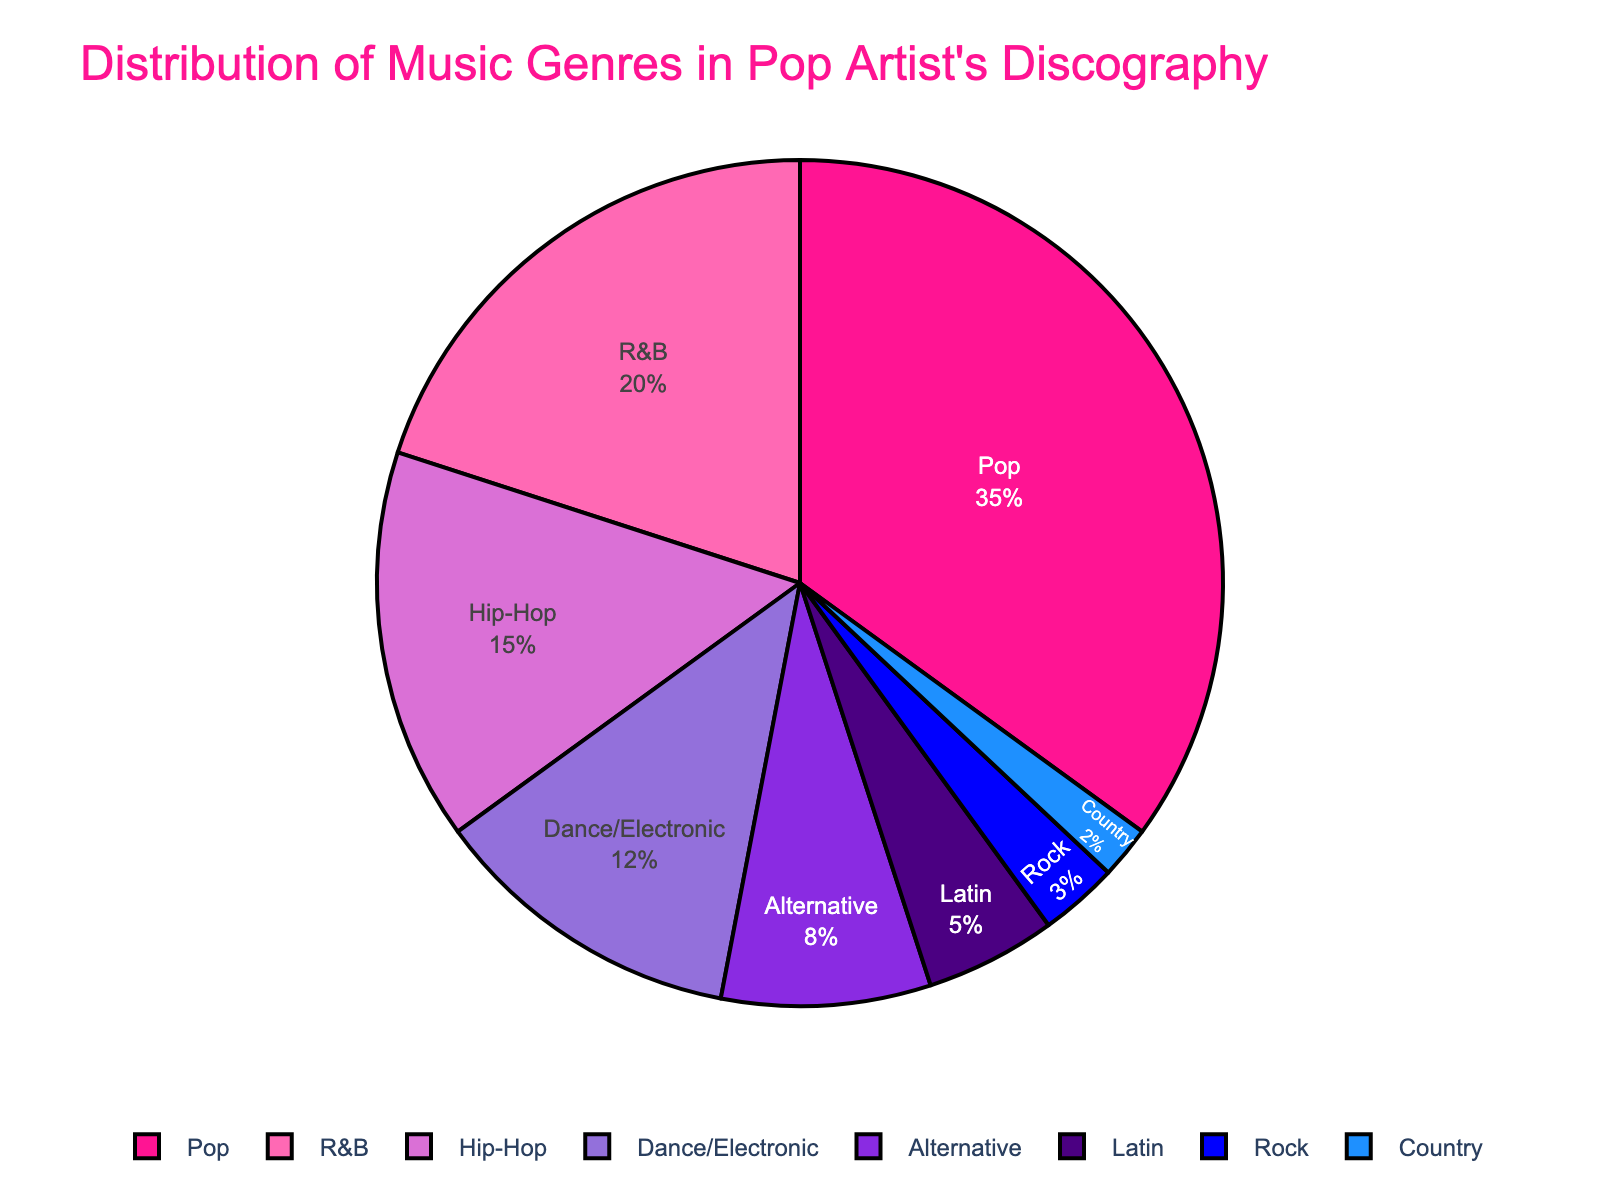Which genre has the largest percentage in the pop artist's discography? The chart shows that the Pop genre has the largest section, taking up 35% of the pie chart.
Answer: Pop Which genre has the smallest percentage in the pop artist's discography? The Country genre has the smallest section in the pie chart, indicated at 2%.
Answer: Country What is the combined percentage of Hip-Hop, Dance/Electronic, and Alternative genres? Sum the percentages for Hip-Hop (15%), Dance/Electronic (12%), and Alternative (8%): 15 + 12 + 8 = 35%
Answer: 35% Is the percentage of R&B greater than the combination of Rock and Country? The percentage of R&B is 20%. The combined percentage of Rock (3%) and Country (2%) is 5%. Since 20% > 5%, yes, R&B is greater.
Answer: Yes Which genres have a percentage less than 10%? The four smallest sections are Alternative (8%), Latin (5%), Rock (3%), and Country (2%).
Answer: Alternative, Latin, Rock, Country How does the percentage of Pop compare to the sum of Latin and Rock? The percentage of Pop is 35%. The sum of Latin (5%) and Rock (3%) is 5 + 3 = 8%. Since 35% > 8%, Pop is larger.
Answer: Pop is larger What is the combined percentage of all genres with more than 10% each? Sum the percentages for Pop (35%), R&B (20%), Hip-Hop (15%), and Dance/Electronic (12%): 35 + 20 + 15 + 12 = 82%
Answer: 82% How does the visual appearance of the Pop section compare to the R&B section? The Pop section is visually larger than the R&B section, both in area and percentage, Pop being 35% and R&B 20%.
Answer: Pop is larger Which genre is represented by the blue color in the pie chart? The blue color in the pie chart represents Hip-Hop, with a percentage of 15%.
Answer: Hip-Hop What is the percentage difference between the Pop and Country genres? Subtract the percentage of Country (2%) from Pop (35%) to find the difference: 35 - 2 = 33%
Answer: 33% 